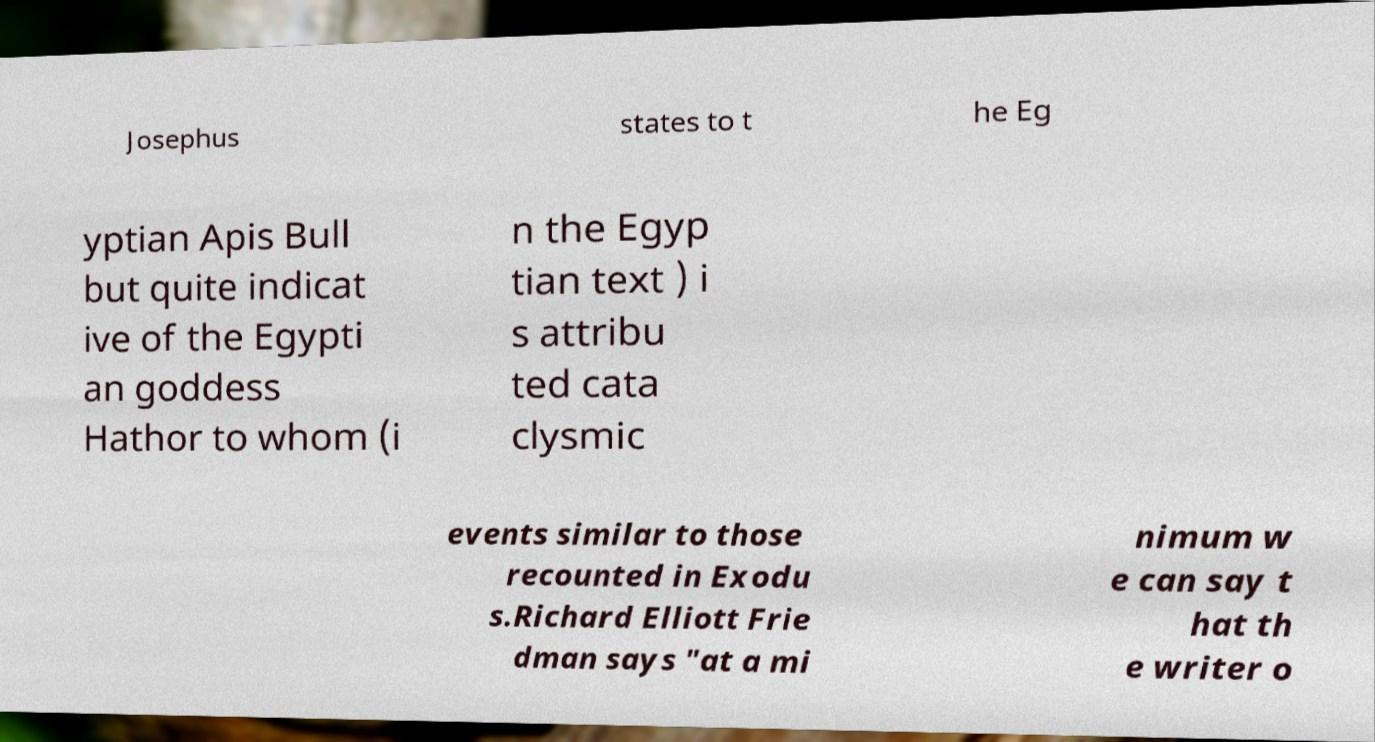I need the written content from this picture converted into text. Can you do that? Josephus states to t he Eg yptian Apis Bull but quite indicat ive of the Egypti an goddess Hathor to whom (i n the Egyp tian text ) i s attribu ted cata clysmic events similar to those recounted in Exodu s.Richard Elliott Frie dman says "at a mi nimum w e can say t hat th e writer o 